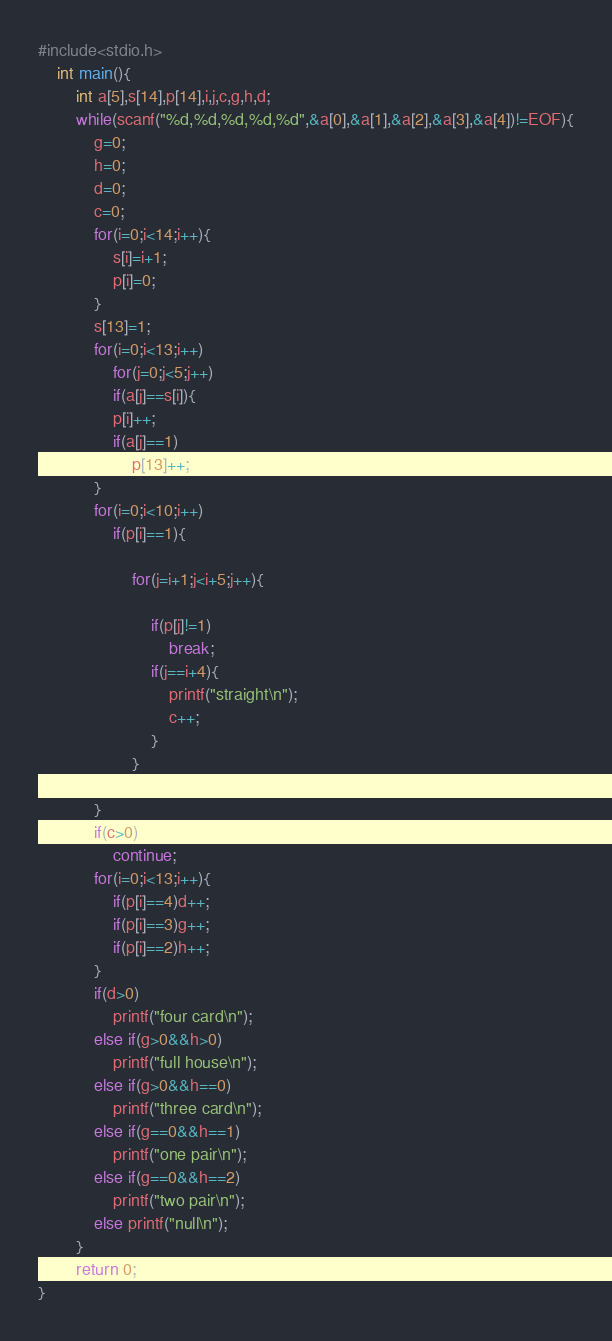Convert code to text. <code><loc_0><loc_0><loc_500><loc_500><_C_>#include<stdio.h>
	int main(){
		int a[5],s[14],p[14],i,j,c,g,h,d;
		while(scanf("%d,%d,%d,%d,%d",&a[0],&a[1],&a[2],&a[3],&a[4])!=EOF){
			g=0;
			h=0;
			d=0;
			c=0;
			for(i=0;i<14;i++){
				s[i]=i+1;
				p[i]=0;
			}
			s[13]=1;
			for(i=0;i<13;i++)
				for(j=0;j<5;j++)
				if(a[j]==s[i]){
				p[i]++;
				if(a[j]==1)
					p[13]++;
			}
			for(i=0;i<10;i++)
				if(p[i]==1){
					
					for(j=i+1;j<i+5;j++){
						
						if(p[j]!=1)
							break;
						if(j==i+4){
							printf("straight\n");
							c++;
						}
					}
					
			}
			if(c>0)
				continue;
			for(i=0;i<13;i++){
				if(p[i]==4)d++;
				if(p[i]==3)g++;
				if(p[i]==2)h++;
			}
			if(d>0)
				printf("four card\n");
			else if(g>0&&h>0)
				printf("full house\n");
			else if(g>0&&h==0)
				printf("three card\n");
			else if(g==0&&h==1)
				printf("one pair\n");
			else if(g==0&&h==2)
				printf("two pair\n");
			else printf("null\n");
		}
		return 0;
}</code> 